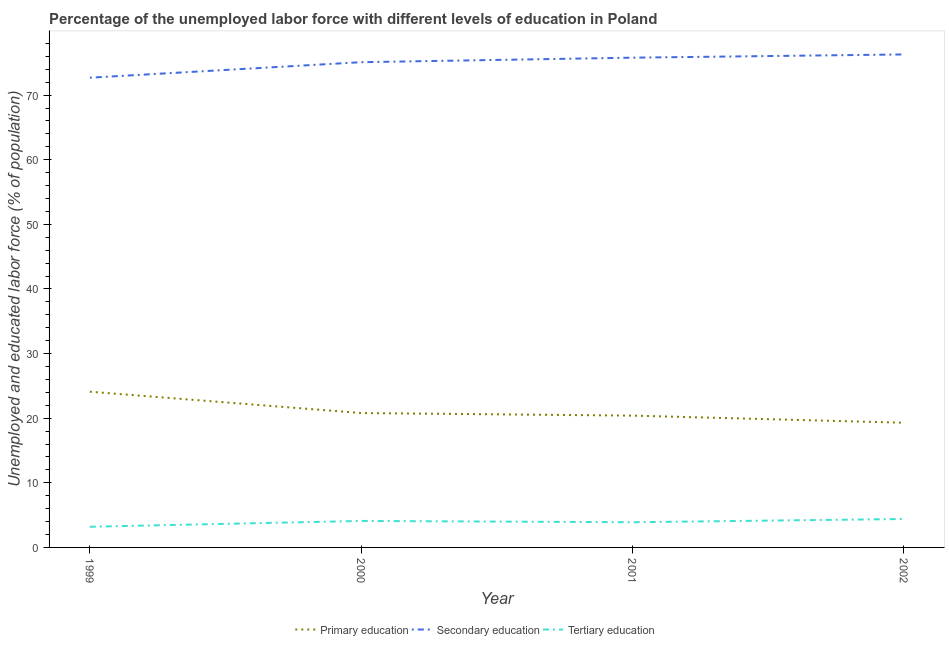Does the line corresponding to percentage of labor force who received primary education intersect with the line corresponding to percentage of labor force who received secondary education?
Your answer should be very brief. No. What is the percentage of labor force who received primary education in 1999?
Offer a terse response. 24.1. Across all years, what is the maximum percentage of labor force who received primary education?
Make the answer very short. 24.1. Across all years, what is the minimum percentage of labor force who received secondary education?
Your answer should be very brief. 72.7. In which year was the percentage of labor force who received tertiary education maximum?
Your response must be concise. 2002. In which year was the percentage of labor force who received primary education minimum?
Ensure brevity in your answer.  2002. What is the total percentage of labor force who received secondary education in the graph?
Give a very brief answer. 299.9. What is the difference between the percentage of labor force who received secondary education in 2000 and that in 2002?
Offer a terse response. -1.2. What is the difference between the percentage of labor force who received tertiary education in 2001 and the percentage of labor force who received primary education in 2000?
Keep it short and to the point. -16.9. What is the average percentage of labor force who received tertiary education per year?
Provide a succinct answer. 3.9. In the year 2000, what is the difference between the percentage of labor force who received primary education and percentage of labor force who received tertiary education?
Your answer should be very brief. 16.7. What is the ratio of the percentage of labor force who received tertiary education in 2000 to that in 2002?
Ensure brevity in your answer.  0.93. What is the difference between the highest and the second highest percentage of labor force who received tertiary education?
Provide a short and direct response. 0.3. What is the difference between the highest and the lowest percentage of labor force who received tertiary education?
Your response must be concise. 1.2. In how many years, is the percentage of labor force who received secondary education greater than the average percentage of labor force who received secondary education taken over all years?
Offer a terse response. 3. Is the sum of the percentage of labor force who received tertiary education in 1999 and 2000 greater than the maximum percentage of labor force who received secondary education across all years?
Make the answer very short. No. Is it the case that in every year, the sum of the percentage of labor force who received primary education and percentage of labor force who received secondary education is greater than the percentage of labor force who received tertiary education?
Offer a terse response. Yes. Does the percentage of labor force who received primary education monotonically increase over the years?
Offer a terse response. No. Is the percentage of labor force who received tertiary education strictly less than the percentage of labor force who received secondary education over the years?
Your answer should be compact. Yes. How many lines are there?
Your answer should be very brief. 3. How many years are there in the graph?
Make the answer very short. 4. Are the values on the major ticks of Y-axis written in scientific E-notation?
Offer a terse response. No. Does the graph contain any zero values?
Your response must be concise. No. How many legend labels are there?
Your answer should be very brief. 3. What is the title of the graph?
Provide a succinct answer. Percentage of the unemployed labor force with different levels of education in Poland. Does "Neonatal" appear as one of the legend labels in the graph?
Your answer should be very brief. No. What is the label or title of the X-axis?
Your answer should be very brief. Year. What is the label or title of the Y-axis?
Give a very brief answer. Unemployed and educated labor force (% of population). What is the Unemployed and educated labor force (% of population) in Primary education in 1999?
Your answer should be very brief. 24.1. What is the Unemployed and educated labor force (% of population) in Secondary education in 1999?
Offer a very short reply. 72.7. What is the Unemployed and educated labor force (% of population) in Tertiary education in 1999?
Your answer should be compact. 3.2. What is the Unemployed and educated labor force (% of population) in Primary education in 2000?
Your answer should be compact. 20.8. What is the Unemployed and educated labor force (% of population) in Secondary education in 2000?
Ensure brevity in your answer.  75.1. What is the Unemployed and educated labor force (% of population) of Tertiary education in 2000?
Your answer should be very brief. 4.1. What is the Unemployed and educated labor force (% of population) of Primary education in 2001?
Offer a terse response. 20.4. What is the Unemployed and educated labor force (% of population) in Secondary education in 2001?
Your answer should be very brief. 75.8. What is the Unemployed and educated labor force (% of population) of Tertiary education in 2001?
Ensure brevity in your answer.  3.9. What is the Unemployed and educated labor force (% of population) in Primary education in 2002?
Make the answer very short. 19.3. What is the Unemployed and educated labor force (% of population) in Secondary education in 2002?
Your answer should be compact. 76.3. What is the Unemployed and educated labor force (% of population) of Tertiary education in 2002?
Your response must be concise. 4.4. Across all years, what is the maximum Unemployed and educated labor force (% of population) of Primary education?
Ensure brevity in your answer.  24.1. Across all years, what is the maximum Unemployed and educated labor force (% of population) of Secondary education?
Your response must be concise. 76.3. Across all years, what is the maximum Unemployed and educated labor force (% of population) in Tertiary education?
Your answer should be very brief. 4.4. Across all years, what is the minimum Unemployed and educated labor force (% of population) in Primary education?
Ensure brevity in your answer.  19.3. Across all years, what is the minimum Unemployed and educated labor force (% of population) in Secondary education?
Offer a very short reply. 72.7. Across all years, what is the minimum Unemployed and educated labor force (% of population) in Tertiary education?
Provide a succinct answer. 3.2. What is the total Unemployed and educated labor force (% of population) of Primary education in the graph?
Your answer should be compact. 84.6. What is the total Unemployed and educated labor force (% of population) of Secondary education in the graph?
Provide a short and direct response. 299.9. What is the difference between the Unemployed and educated labor force (% of population) in Secondary education in 1999 and that in 2000?
Provide a succinct answer. -2.4. What is the difference between the Unemployed and educated labor force (% of population) of Tertiary education in 1999 and that in 2000?
Your response must be concise. -0.9. What is the difference between the Unemployed and educated labor force (% of population) in Primary education in 1999 and that in 2001?
Provide a short and direct response. 3.7. What is the difference between the Unemployed and educated labor force (% of population) in Secondary education in 1999 and that in 2001?
Your answer should be compact. -3.1. What is the difference between the Unemployed and educated labor force (% of population) of Tertiary education in 1999 and that in 2001?
Give a very brief answer. -0.7. What is the difference between the Unemployed and educated labor force (% of population) of Primary education in 2000 and that in 2001?
Make the answer very short. 0.4. What is the difference between the Unemployed and educated labor force (% of population) in Secondary education in 2000 and that in 2001?
Provide a succinct answer. -0.7. What is the difference between the Unemployed and educated labor force (% of population) in Tertiary education in 2000 and that in 2001?
Offer a very short reply. 0.2. What is the difference between the Unemployed and educated labor force (% of population) in Primary education in 2000 and that in 2002?
Your answer should be very brief. 1.5. What is the difference between the Unemployed and educated labor force (% of population) of Secondary education in 2000 and that in 2002?
Make the answer very short. -1.2. What is the difference between the Unemployed and educated labor force (% of population) in Tertiary education in 2001 and that in 2002?
Give a very brief answer. -0.5. What is the difference between the Unemployed and educated labor force (% of population) in Primary education in 1999 and the Unemployed and educated labor force (% of population) in Secondary education in 2000?
Provide a short and direct response. -51. What is the difference between the Unemployed and educated labor force (% of population) of Primary education in 1999 and the Unemployed and educated labor force (% of population) of Tertiary education in 2000?
Provide a succinct answer. 20. What is the difference between the Unemployed and educated labor force (% of population) of Secondary education in 1999 and the Unemployed and educated labor force (% of population) of Tertiary education in 2000?
Provide a succinct answer. 68.6. What is the difference between the Unemployed and educated labor force (% of population) of Primary education in 1999 and the Unemployed and educated labor force (% of population) of Secondary education in 2001?
Offer a very short reply. -51.7. What is the difference between the Unemployed and educated labor force (% of population) of Primary education in 1999 and the Unemployed and educated labor force (% of population) of Tertiary education in 2001?
Provide a short and direct response. 20.2. What is the difference between the Unemployed and educated labor force (% of population) in Secondary education in 1999 and the Unemployed and educated labor force (% of population) in Tertiary education in 2001?
Provide a succinct answer. 68.8. What is the difference between the Unemployed and educated labor force (% of population) in Primary education in 1999 and the Unemployed and educated labor force (% of population) in Secondary education in 2002?
Offer a very short reply. -52.2. What is the difference between the Unemployed and educated labor force (% of population) in Primary education in 1999 and the Unemployed and educated labor force (% of population) in Tertiary education in 2002?
Give a very brief answer. 19.7. What is the difference between the Unemployed and educated labor force (% of population) of Secondary education in 1999 and the Unemployed and educated labor force (% of population) of Tertiary education in 2002?
Offer a very short reply. 68.3. What is the difference between the Unemployed and educated labor force (% of population) of Primary education in 2000 and the Unemployed and educated labor force (% of population) of Secondary education in 2001?
Give a very brief answer. -55. What is the difference between the Unemployed and educated labor force (% of population) of Secondary education in 2000 and the Unemployed and educated labor force (% of population) of Tertiary education in 2001?
Offer a very short reply. 71.2. What is the difference between the Unemployed and educated labor force (% of population) of Primary education in 2000 and the Unemployed and educated labor force (% of population) of Secondary education in 2002?
Your response must be concise. -55.5. What is the difference between the Unemployed and educated labor force (% of population) of Primary education in 2000 and the Unemployed and educated labor force (% of population) of Tertiary education in 2002?
Offer a very short reply. 16.4. What is the difference between the Unemployed and educated labor force (% of population) of Secondary education in 2000 and the Unemployed and educated labor force (% of population) of Tertiary education in 2002?
Provide a short and direct response. 70.7. What is the difference between the Unemployed and educated labor force (% of population) in Primary education in 2001 and the Unemployed and educated labor force (% of population) in Secondary education in 2002?
Give a very brief answer. -55.9. What is the difference between the Unemployed and educated labor force (% of population) of Primary education in 2001 and the Unemployed and educated labor force (% of population) of Tertiary education in 2002?
Provide a succinct answer. 16. What is the difference between the Unemployed and educated labor force (% of population) in Secondary education in 2001 and the Unemployed and educated labor force (% of population) in Tertiary education in 2002?
Provide a succinct answer. 71.4. What is the average Unemployed and educated labor force (% of population) in Primary education per year?
Keep it short and to the point. 21.15. What is the average Unemployed and educated labor force (% of population) in Secondary education per year?
Make the answer very short. 74.97. What is the average Unemployed and educated labor force (% of population) in Tertiary education per year?
Your answer should be compact. 3.9. In the year 1999, what is the difference between the Unemployed and educated labor force (% of population) in Primary education and Unemployed and educated labor force (% of population) in Secondary education?
Your answer should be very brief. -48.6. In the year 1999, what is the difference between the Unemployed and educated labor force (% of population) of Primary education and Unemployed and educated labor force (% of population) of Tertiary education?
Give a very brief answer. 20.9. In the year 1999, what is the difference between the Unemployed and educated labor force (% of population) of Secondary education and Unemployed and educated labor force (% of population) of Tertiary education?
Make the answer very short. 69.5. In the year 2000, what is the difference between the Unemployed and educated labor force (% of population) in Primary education and Unemployed and educated labor force (% of population) in Secondary education?
Provide a succinct answer. -54.3. In the year 2000, what is the difference between the Unemployed and educated labor force (% of population) in Primary education and Unemployed and educated labor force (% of population) in Tertiary education?
Your answer should be compact. 16.7. In the year 2000, what is the difference between the Unemployed and educated labor force (% of population) of Secondary education and Unemployed and educated labor force (% of population) of Tertiary education?
Provide a succinct answer. 71. In the year 2001, what is the difference between the Unemployed and educated labor force (% of population) of Primary education and Unemployed and educated labor force (% of population) of Secondary education?
Your answer should be compact. -55.4. In the year 2001, what is the difference between the Unemployed and educated labor force (% of population) in Secondary education and Unemployed and educated labor force (% of population) in Tertiary education?
Your response must be concise. 71.9. In the year 2002, what is the difference between the Unemployed and educated labor force (% of population) of Primary education and Unemployed and educated labor force (% of population) of Secondary education?
Your answer should be compact. -57. In the year 2002, what is the difference between the Unemployed and educated labor force (% of population) of Primary education and Unemployed and educated labor force (% of population) of Tertiary education?
Ensure brevity in your answer.  14.9. In the year 2002, what is the difference between the Unemployed and educated labor force (% of population) in Secondary education and Unemployed and educated labor force (% of population) in Tertiary education?
Give a very brief answer. 71.9. What is the ratio of the Unemployed and educated labor force (% of population) of Primary education in 1999 to that in 2000?
Ensure brevity in your answer.  1.16. What is the ratio of the Unemployed and educated labor force (% of population) in Secondary education in 1999 to that in 2000?
Keep it short and to the point. 0.97. What is the ratio of the Unemployed and educated labor force (% of population) of Tertiary education in 1999 to that in 2000?
Your answer should be compact. 0.78. What is the ratio of the Unemployed and educated labor force (% of population) of Primary education in 1999 to that in 2001?
Your response must be concise. 1.18. What is the ratio of the Unemployed and educated labor force (% of population) in Secondary education in 1999 to that in 2001?
Provide a succinct answer. 0.96. What is the ratio of the Unemployed and educated labor force (% of population) in Tertiary education in 1999 to that in 2001?
Keep it short and to the point. 0.82. What is the ratio of the Unemployed and educated labor force (% of population) of Primary education in 1999 to that in 2002?
Ensure brevity in your answer.  1.25. What is the ratio of the Unemployed and educated labor force (% of population) in Secondary education in 1999 to that in 2002?
Provide a short and direct response. 0.95. What is the ratio of the Unemployed and educated labor force (% of population) of Tertiary education in 1999 to that in 2002?
Your answer should be compact. 0.73. What is the ratio of the Unemployed and educated labor force (% of population) in Primary education in 2000 to that in 2001?
Your answer should be compact. 1.02. What is the ratio of the Unemployed and educated labor force (% of population) of Secondary education in 2000 to that in 2001?
Ensure brevity in your answer.  0.99. What is the ratio of the Unemployed and educated labor force (% of population) of Tertiary education in 2000 to that in 2001?
Your answer should be compact. 1.05. What is the ratio of the Unemployed and educated labor force (% of population) in Primary education in 2000 to that in 2002?
Your answer should be compact. 1.08. What is the ratio of the Unemployed and educated labor force (% of population) of Secondary education in 2000 to that in 2002?
Your answer should be very brief. 0.98. What is the ratio of the Unemployed and educated labor force (% of population) in Tertiary education in 2000 to that in 2002?
Keep it short and to the point. 0.93. What is the ratio of the Unemployed and educated labor force (% of population) of Primary education in 2001 to that in 2002?
Provide a succinct answer. 1.06. What is the ratio of the Unemployed and educated labor force (% of population) of Secondary education in 2001 to that in 2002?
Your response must be concise. 0.99. What is the ratio of the Unemployed and educated labor force (% of population) of Tertiary education in 2001 to that in 2002?
Offer a very short reply. 0.89. What is the difference between the highest and the lowest Unemployed and educated labor force (% of population) in Tertiary education?
Make the answer very short. 1.2. 